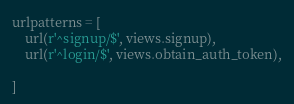<code> <loc_0><loc_0><loc_500><loc_500><_Python_>
urlpatterns = [
    url(r'^signup/$', views.signup),
    url(r'^login/$', views.obtain_auth_token),

]
</code> 